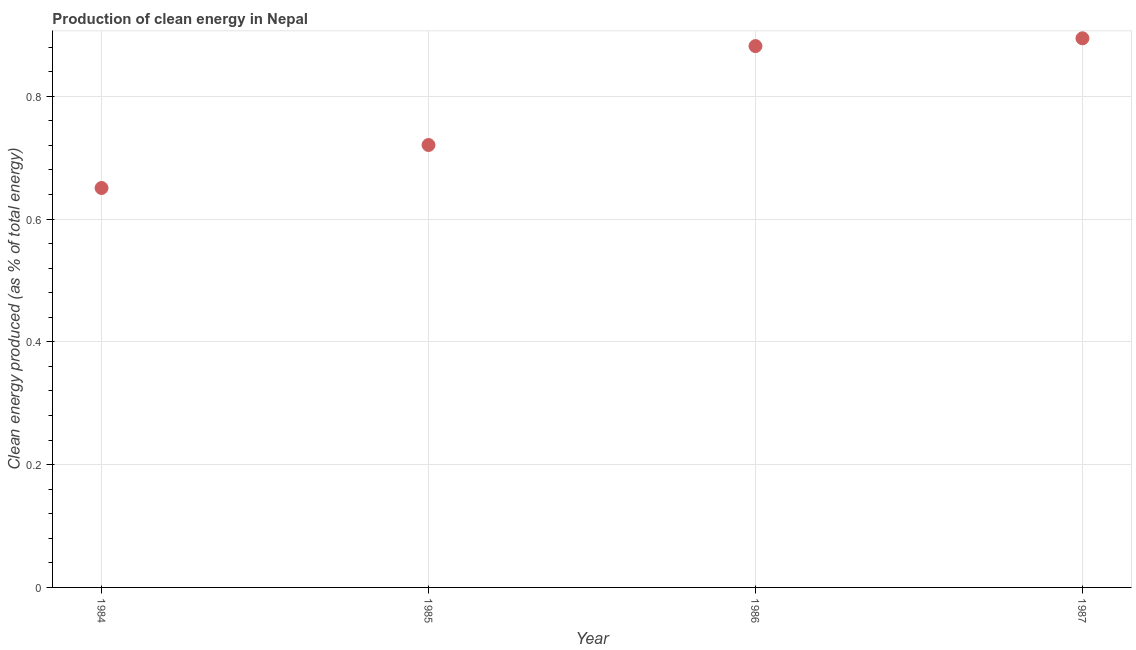What is the production of clean energy in 1987?
Ensure brevity in your answer.  0.89. Across all years, what is the maximum production of clean energy?
Make the answer very short. 0.89. Across all years, what is the minimum production of clean energy?
Offer a very short reply. 0.65. In which year was the production of clean energy maximum?
Make the answer very short. 1987. In which year was the production of clean energy minimum?
Provide a succinct answer. 1984. What is the sum of the production of clean energy?
Your answer should be very brief. 3.15. What is the difference between the production of clean energy in 1986 and 1987?
Offer a very short reply. -0.01. What is the average production of clean energy per year?
Your answer should be compact. 0.79. What is the median production of clean energy?
Offer a very short reply. 0.8. In how many years, is the production of clean energy greater than 0.7600000000000001 %?
Offer a terse response. 2. Do a majority of the years between 1985 and 1987 (inclusive) have production of clean energy greater than 0.32 %?
Provide a short and direct response. Yes. What is the ratio of the production of clean energy in 1984 to that in 1987?
Provide a succinct answer. 0.73. What is the difference between the highest and the second highest production of clean energy?
Keep it short and to the point. 0.01. Is the sum of the production of clean energy in 1984 and 1987 greater than the maximum production of clean energy across all years?
Keep it short and to the point. Yes. What is the difference between the highest and the lowest production of clean energy?
Provide a short and direct response. 0.24. Does the production of clean energy monotonically increase over the years?
Provide a short and direct response. Yes. How many dotlines are there?
Provide a succinct answer. 1. How many years are there in the graph?
Provide a succinct answer. 4. Does the graph contain any zero values?
Give a very brief answer. No. Does the graph contain grids?
Offer a very short reply. Yes. What is the title of the graph?
Your response must be concise. Production of clean energy in Nepal. What is the label or title of the X-axis?
Provide a short and direct response. Year. What is the label or title of the Y-axis?
Provide a succinct answer. Clean energy produced (as % of total energy). What is the Clean energy produced (as % of total energy) in 1984?
Your answer should be very brief. 0.65. What is the Clean energy produced (as % of total energy) in 1985?
Provide a succinct answer. 0.72. What is the Clean energy produced (as % of total energy) in 1986?
Provide a short and direct response. 0.88. What is the Clean energy produced (as % of total energy) in 1987?
Your response must be concise. 0.89. What is the difference between the Clean energy produced (as % of total energy) in 1984 and 1985?
Keep it short and to the point. -0.07. What is the difference between the Clean energy produced (as % of total energy) in 1984 and 1986?
Keep it short and to the point. -0.23. What is the difference between the Clean energy produced (as % of total energy) in 1984 and 1987?
Provide a short and direct response. -0.24. What is the difference between the Clean energy produced (as % of total energy) in 1985 and 1986?
Ensure brevity in your answer.  -0.16. What is the difference between the Clean energy produced (as % of total energy) in 1985 and 1987?
Your answer should be very brief. -0.17. What is the difference between the Clean energy produced (as % of total energy) in 1986 and 1987?
Offer a very short reply. -0.01. What is the ratio of the Clean energy produced (as % of total energy) in 1984 to that in 1985?
Keep it short and to the point. 0.9. What is the ratio of the Clean energy produced (as % of total energy) in 1984 to that in 1986?
Provide a short and direct response. 0.74. What is the ratio of the Clean energy produced (as % of total energy) in 1984 to that in 1987?
Keep it short and to the point. 0.73. What is the ratio of the Clean energy produced (as % of total energy) in 1985 to that in 1986?
Ensure brevity in your answer.  0.82. What is the ratio of the Clean energy produced (as % of total energy) in 1985 to that in 1987?
Your answer should be compact. 0.81. What is the ratio of the Clean energy produced (as % of total energy) in 1986 to that in 1987?
Give a very brief answer. 0.99. 